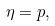Convert formula to latex. <formula><loc_0><loc_0><loc_500><loc_500>\eta = p ,</formula> 